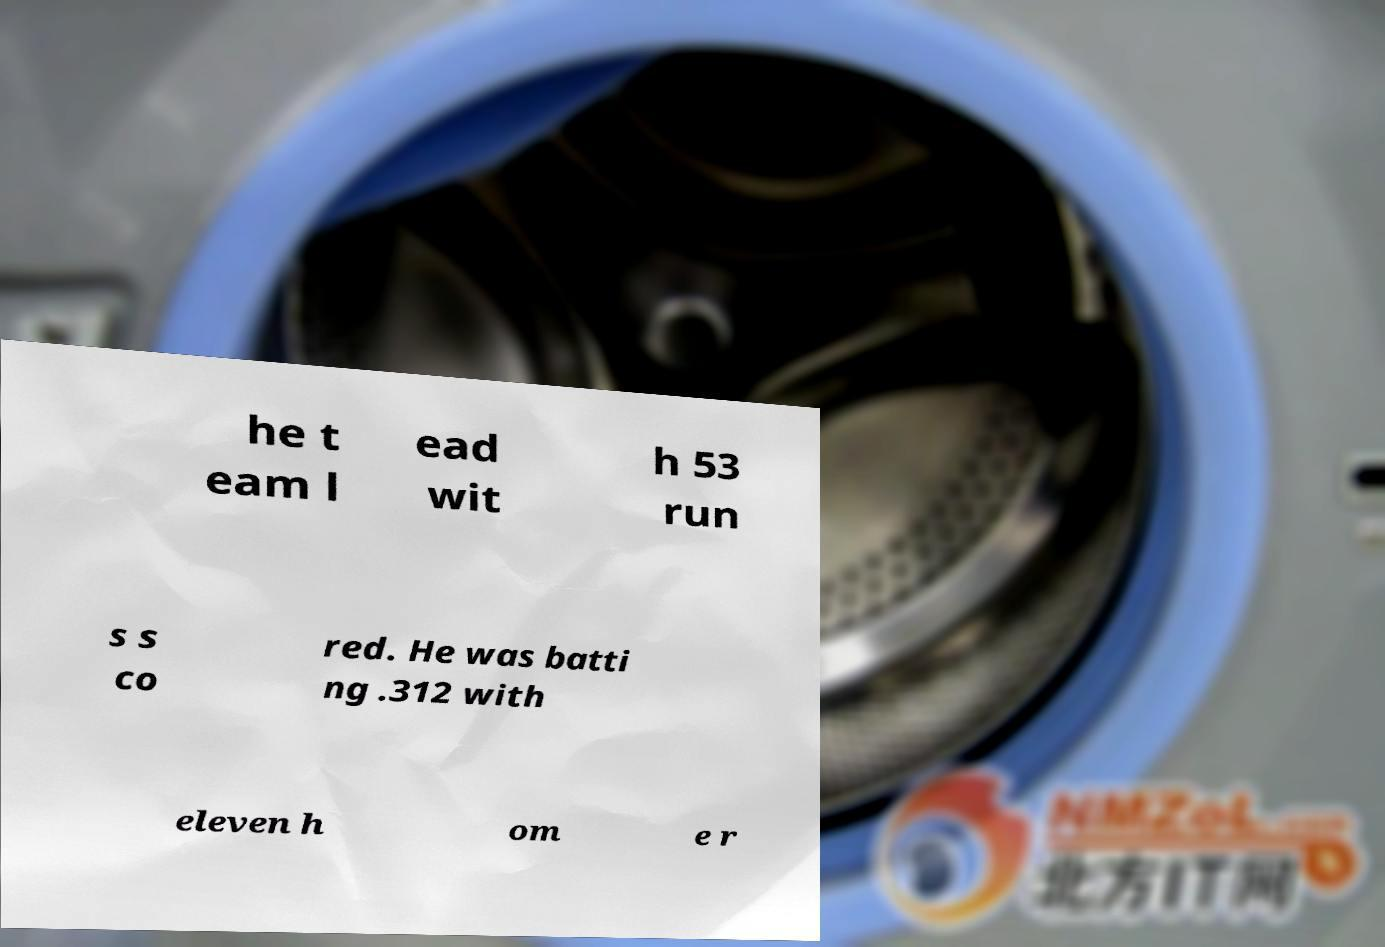There's text embedded in this image that I need extracted. Can you transcribe it verbatim? he t eam l ead wit h 53 run s s co red. He was batti ng .312 with eleven h om e r 